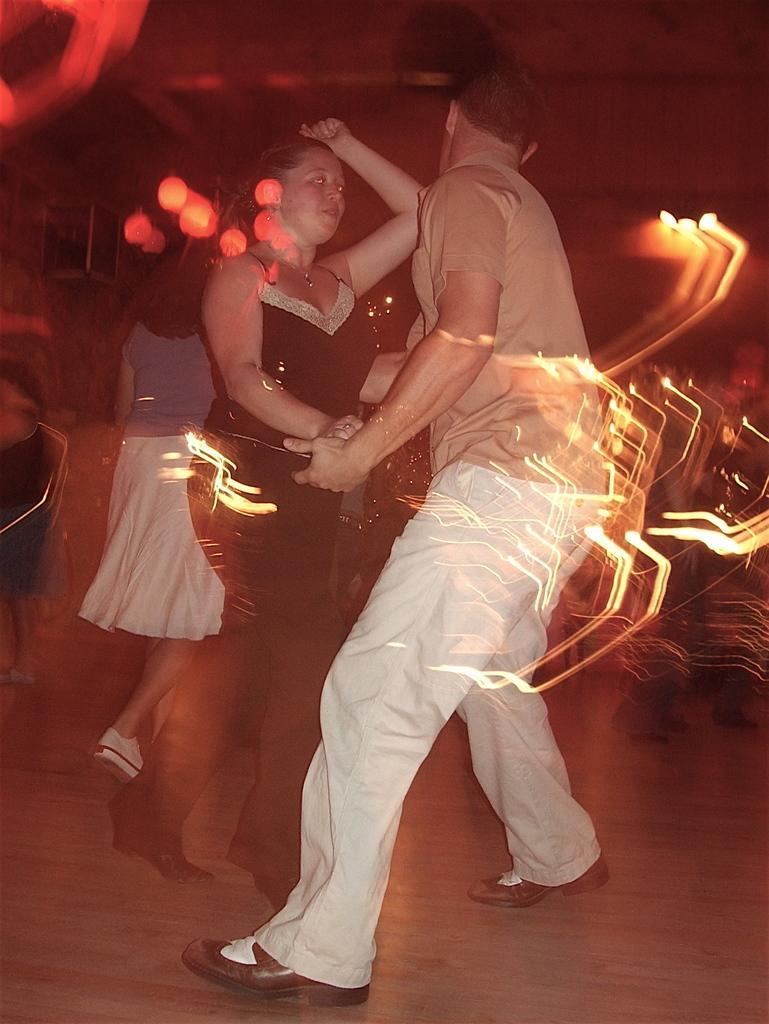How would you summarize this image in a sentence or two? In this image we can see there are two persons are dancing on the floor, beside this person there is another girl walking. The background is blurred. 